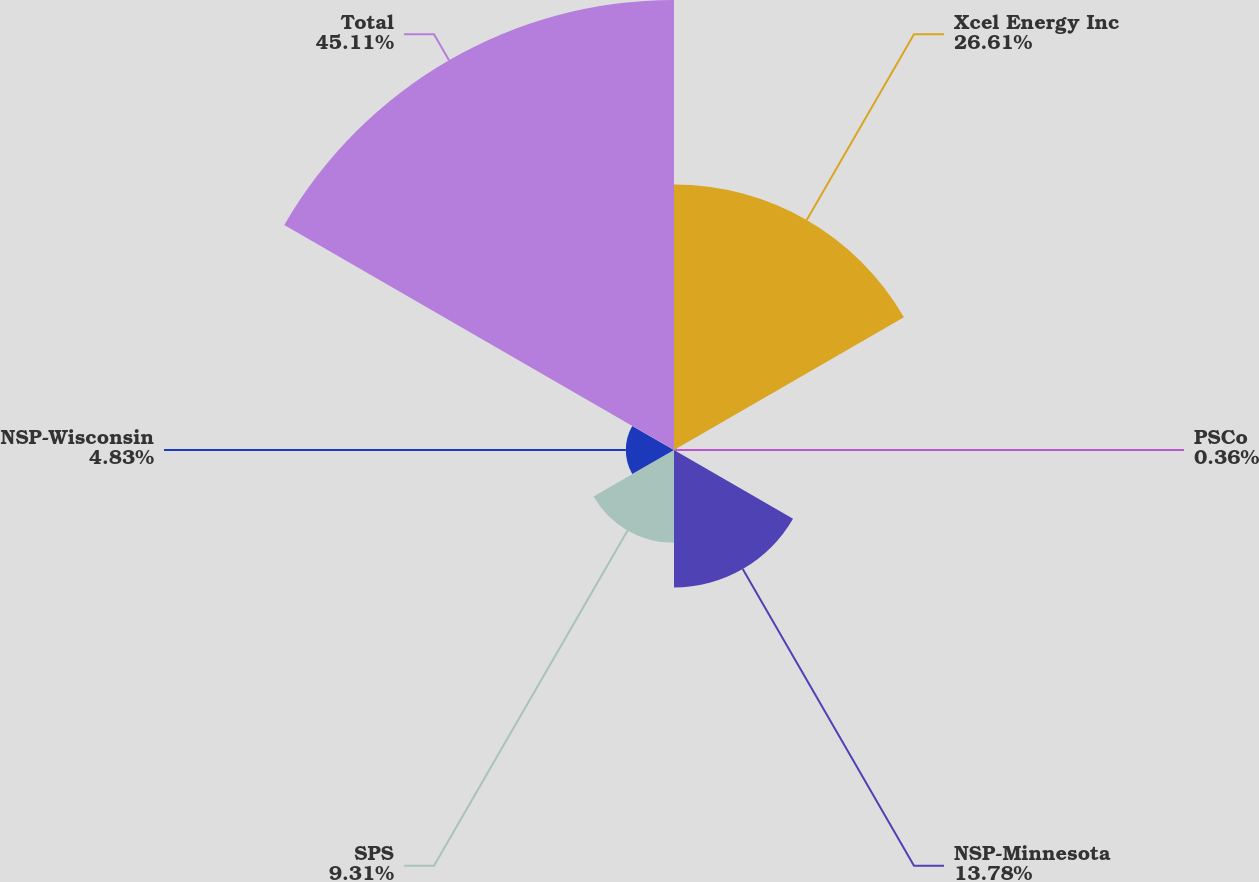<chart> <loc_0><loc_0><loc_500><loc_500><pie_chart><fcel>Xcel Energy Inc<fcel>PSCo<fcel>NSP-Minnesota<fcel>SPS<fcel>NSP-Wisconsin<fcel>Total<nl><fcel>26.61%<fcel>0.36%<fcel>13.78%<fcel>9.31%<fcel>4.83%<fcel>45.11%<nl></chart> 